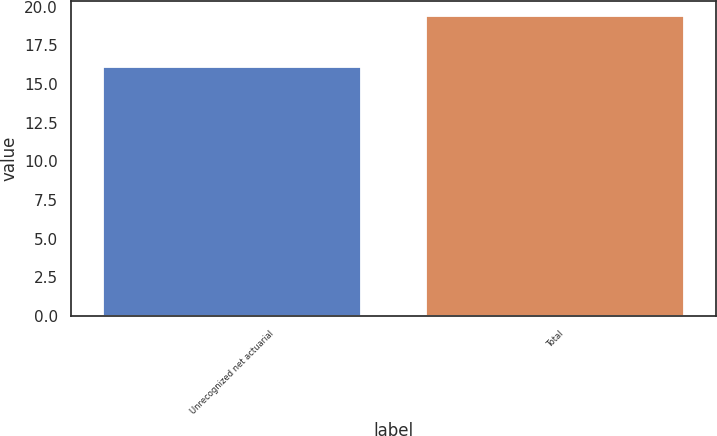Convert chart. <chart><loc_0><loc_0><loc_500><loc_500><bar_chart><fcel>Unrecognized net actuarial<fcel>Total<nl><fcel>16.1<fcel>19.4<nl></chart> 